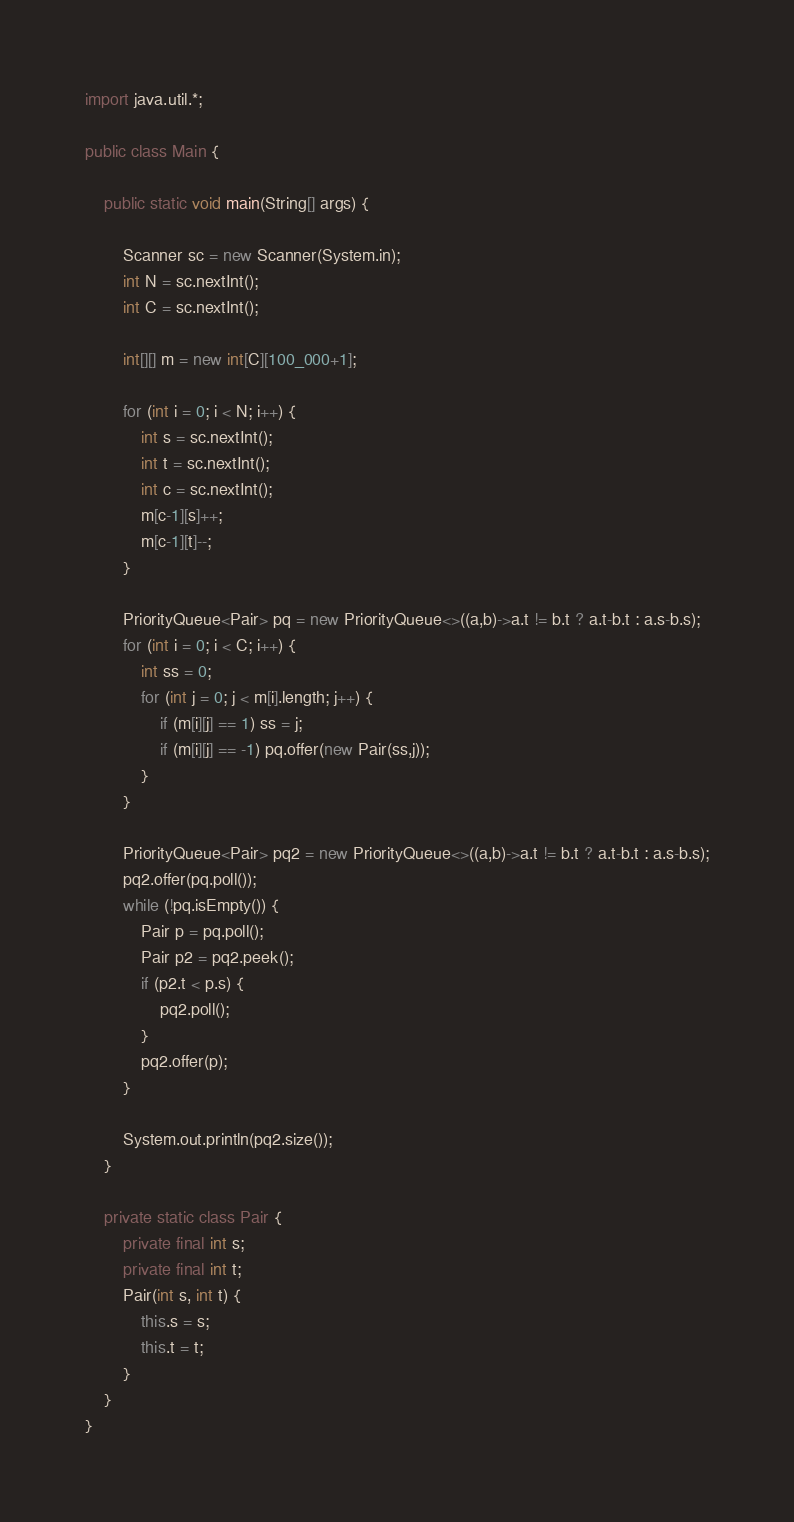Convert code to text. <code><loc_0><loc_0><loc_500><loc_500><_Java_>import java.util.*;

public class Main {

    public static void main(String[] args) {

        Scanner sc = new Scanner(System.in);
        int N = sc.nextInt();
        int C = sc.nextInt();

        int[][] m = new int[C][100_000+1];

        for (int i = 0; i < N; i++) {
            int s = sc.nextInt();
            int t = sc.nextInt();
            int c = sc.nextInt();
            m[c-1][s]++;
            m[c-1][t]--;
        }

        PriorityQueue<Pair> pq = new PriorityQueue<>((a,b)->a.t != b.t ? a.t-b.t : a.s-b.s);
        for (int i = 0; i < C; i++) {
            int ss = 0;
            for (int j = 0; j < m[i].length; j++) {
                if (m[i][j] == 1) ss = j;
                if (m[i][j] == -1) pq.offer(new Pair(ss,j));
            }
        }

        PriorityQueue<Pair> pq2 = new PriorityQueue<>((a,b)->a.t != b.t ? a.t-b.t : a.s-b.s);
        pq2.offer(pq.poll());
        while (!pq.isEmpty()) {
            Pair p = pq.poll();
            Pair p2 = pq2.peek();
            if (p2.t < p.s) {
                pq2.poll();
            }
            pq2.offer(p);
        }

        System.out.println(pq2.size());
    }

    private static class Pair {
        private final int s;
        private final int t;
        Pair(int s, int t) {
            this.s = s;
            this.t = t;
        }
    }
}
</code> 